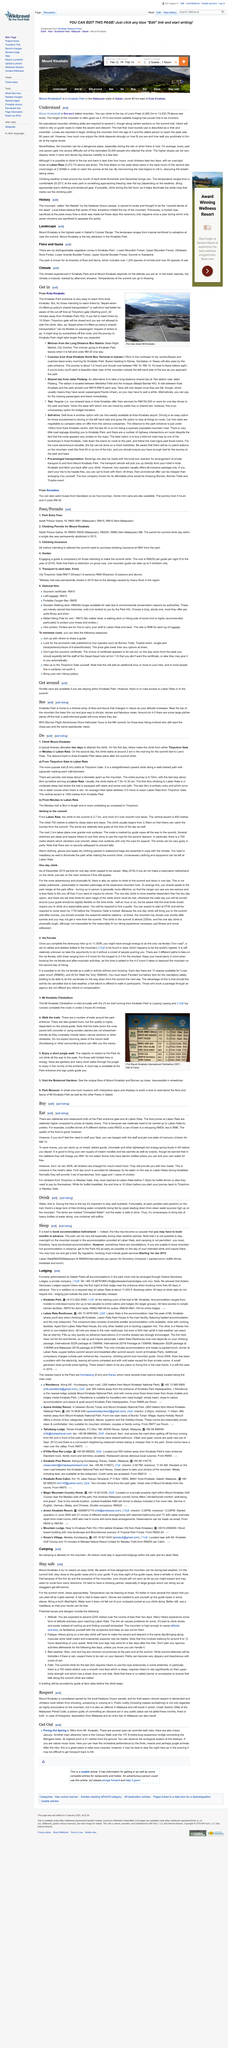Outline some significant characteristics in this image. Mount Kinabalu is the tallest mountain in Borneo. The Timpohon gate closes at 10:30 a.m. Mount Kinabalu, a renowned mountain peak, is located in Kinabalu Park, a protected area situated in the Malaysian state of Sabah, some 80 kilometers east of Kota Kinabalu. The oldest person to reach the peak of Mount Kinabalu was 80 years old. Timophon gate is located approximately 20 minutes away from the Kinabalu Park Headquarters. 